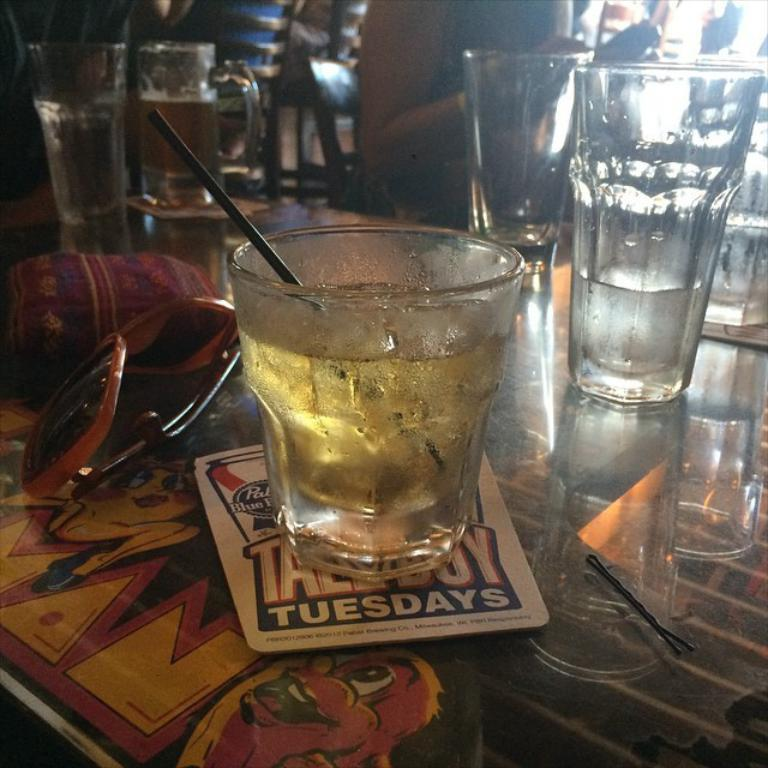What type of furniture is in the image? There is a table in the image. What items are placed on the table? Sunglasses, a slide, glasses, and coasters are visible on the table. What might be used to protect the table from condensation or heat? Coasters are placed on the table for this purpose. Can you describe the people in the background of the image? Unfortunately, the provided facts do not give any information about the people in the background. How many giraffes can be seen on the table in the image? There are no giraffes present on the table in the image. What type of son is playing the slide on the table? There is no son or any person playing the slide in the image; it is just a slide on the table. 